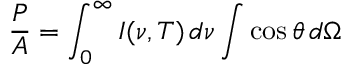Convert formula to latex. <formula><loc_0><loc_0><loc_500><loc_500>{ \frac { P } { A } } = \int _ { 0 } ^ { \infty } I ( \nu , T ) \, d \nu \int \cos \theta \, d \Omega</formula> 